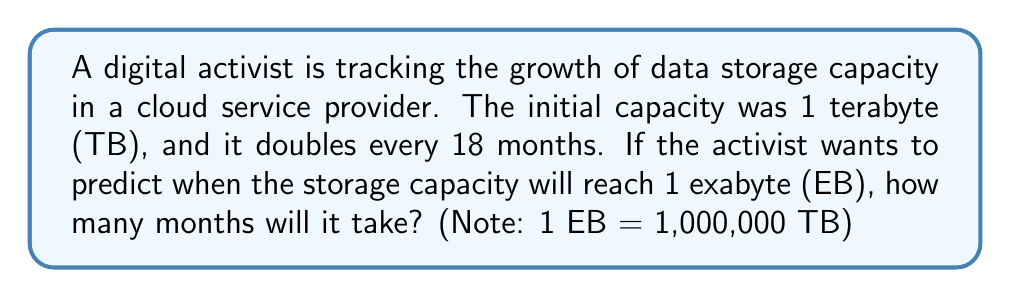Can you answer this question? Let's approach this step-by-step:

1) We start with 1 TB and need to reach 1,000,000 TB (1 EB).

2) The capacity doubles every 18 months, so we can express this as an exponential function:

   $C(t) = 1 \cdot 2^{\frac{t}{18}}$

   Where $C(t)$ is the capacity in TB after $t$ months.

3) We need to find $t$ when $C(t) = 1,000,000$:

   $1,000,000 = 1 \cdot 2^{\frac{t}{18}}$

4) Simplify:

   $1,000,000 = 2^{\frac{t}{18}}$

5) Take the logarithm (base 2) of both sides:

   $\log_2(1,000,000) = \frac{t}{18}$

6) Solve for $t$:

   $t = 18 \cdot \log_2(1,000,000)$

7) Calculate:
   
   $\log_2(1,000,000) \approx 19.93$

   $t = 18 \cdot 19.93 \approx 358.74$

8) Round up to the nearest month:

   $t = 359$ months
Answer: 359 months 